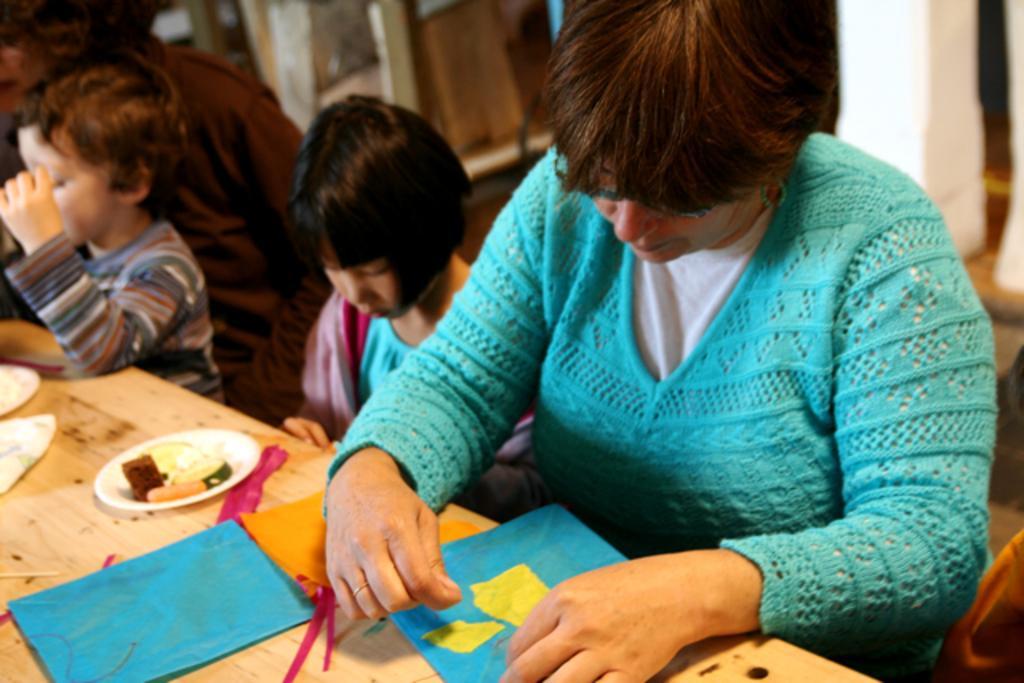How would you summarize this image in a sentence or two? There are three people sitting and the boy standing. This is the table with papers,plate of food and some things on it. 